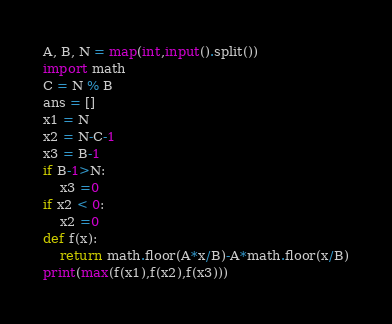Convert code to text. <code><loc_0><loc_0><loc_500><loc_500><_Python_>A, B, N = map(int,input().split())
import math
C = N % B
ans = []
x1 = N
x2 = N-C-1
x3 = B-1
if B-1>N:
    x3 =0
if x2 < 0:
    x2 =0
def f(x):
    return math.floor(A*x/B)-A*math.floor(x/B)
print(max(f(x1),f(x2),f(x3)))</code> 